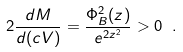Convert formula to latex. <formula><loc_0><loc_0><loc_500><loc_500>2 \frac { d M } { d ( c V ) } = \frac { \Phi _ { B } ^ { 2 } ( z ) } { e ^ { 2 z ^ { 2 } } } > 0 \ .</formula> 